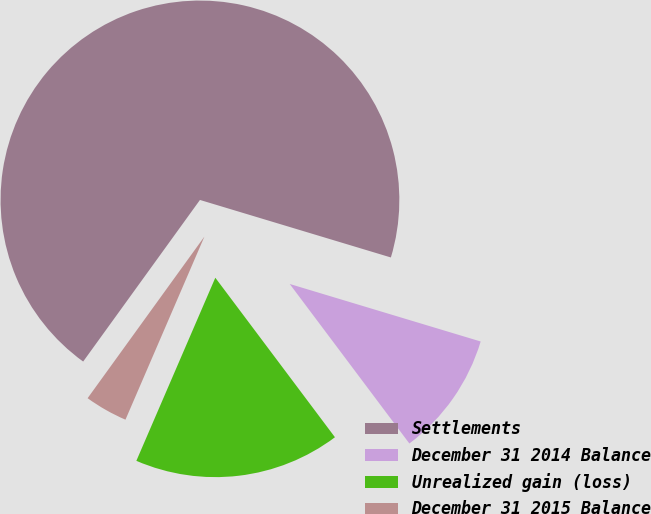Convert chart. <chart><loc_0><loc_0><loc_500><loc_500><pie_chart><fcel>Settlements<fcel>December 31 2014 Balance<fcel>Unrealized gain (loss)<fcel>December 31 2015 Balance<nl><fcel>69.69%<fcel>10.1%<fcel>16.72%<fcel>3.48%<nl></chart> 